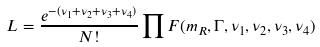Convert formula to latex. <formula><loc_0><loc_0><loc_500><loc_500>L = \frac { e ^ { - ( \nu _ { 1 } + \nu _ { 2 } + \nu _ { 3 } + \nu _ { 4 } ) } } { N ! } \prod F ( m _ { R } , \Gamma , \nu _ { 1 } , \nu _ { 2 } , \nu _ { 3 } , \nu _ { 4 } )</formula> 